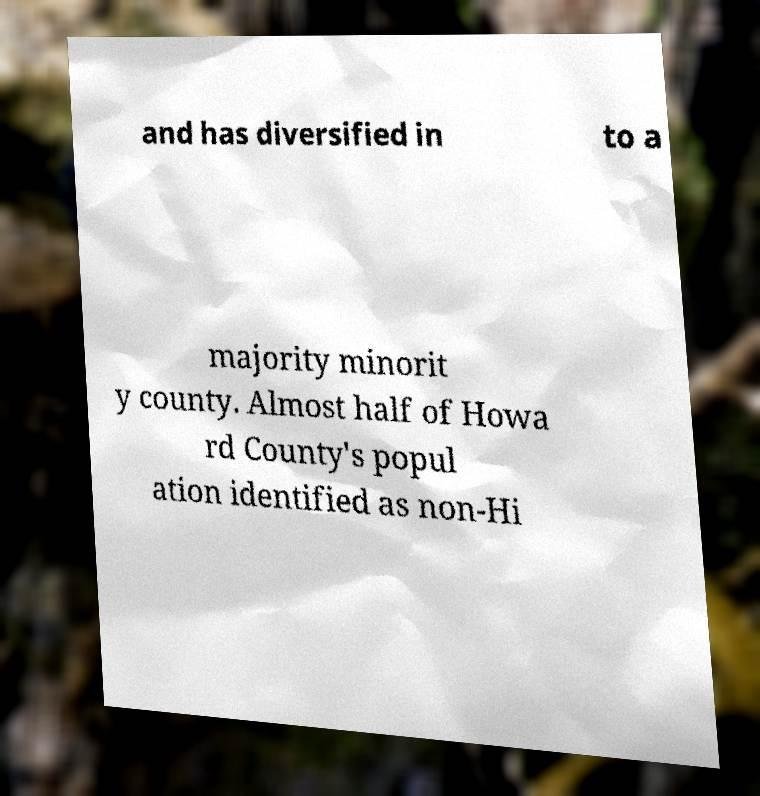Can you accurately transcribe the text from the provided image for me? and has diversified in to a majority minorit y county. Almost half of Howa rd County's popul ation identified as non-Hi 